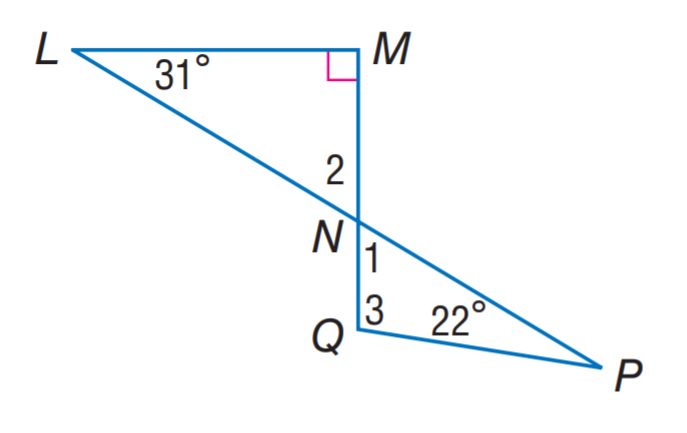Answer the mathemtical geometry problem and directly provide the correct option letter.
Question: Find m \angle 1.
Choices: A: 31 B: 42 C: 59 D: 63 C 